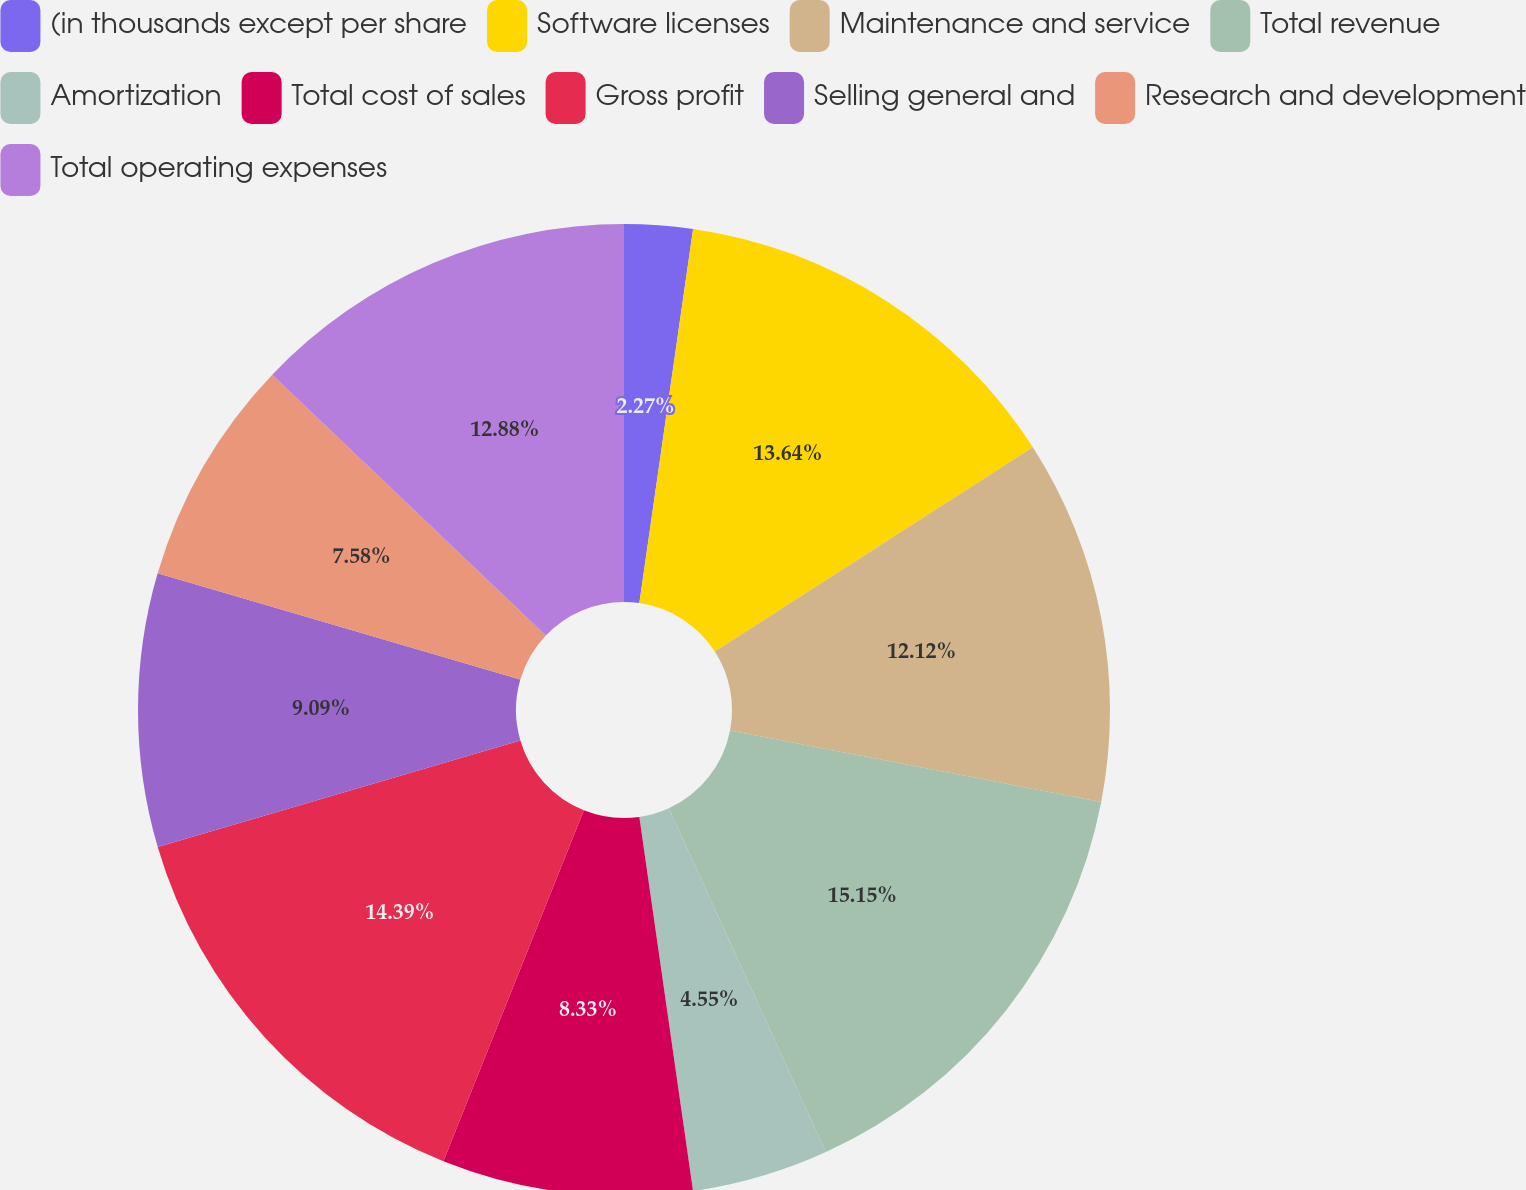Convert chart. <chart><loc_0><loc_0><loc_500><loc_500><pie_chart><fcel>(in thousands except per share<fcel>Software licenses<fcel>Maintenance and service<fcel>Total revenue<fcel>Amortization<fcel>Total cost of sales<fcel>Gross profit<fcel>Selling general and<fcel>Research and development<fcel>Total operating expenses<nl><fcel>2.27%<fcel>13.64%<fcel>12.12%<fcel>15.15%<fcel>4.55%<fcel>8.33%<fcel>14.39%<fcel>9.09%<fcel>7.58%<fcel>12.88%<nl></chart> 